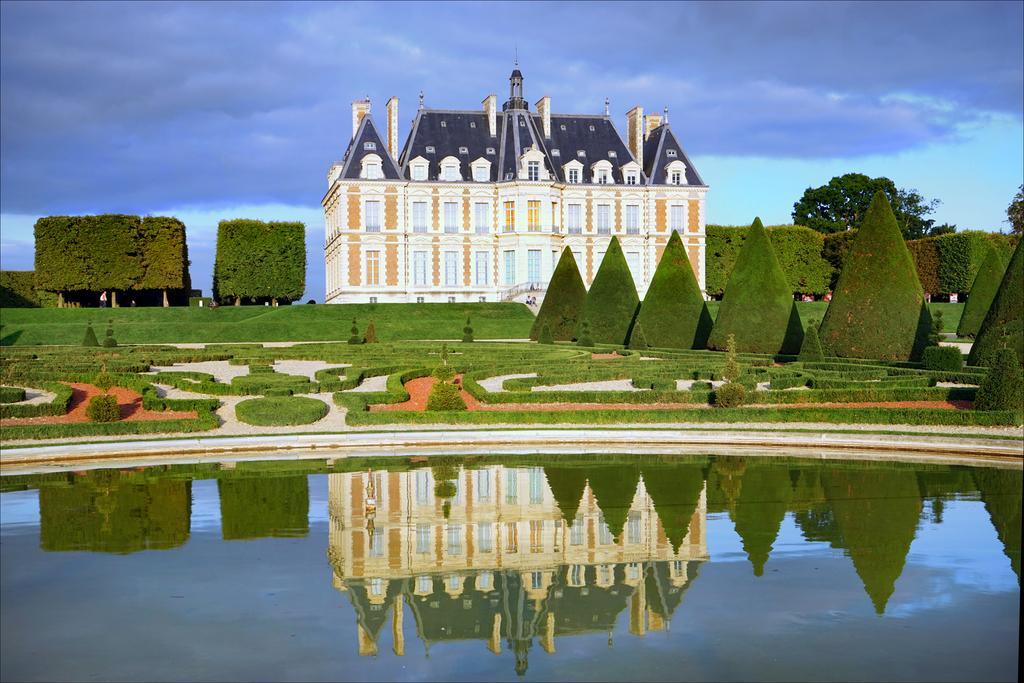How would you summarize this image in a sentence or two? In this image in the front there is water. In the background there are plants, trees and there is a castle and the sky is cloudy and there's grass on the ground. 